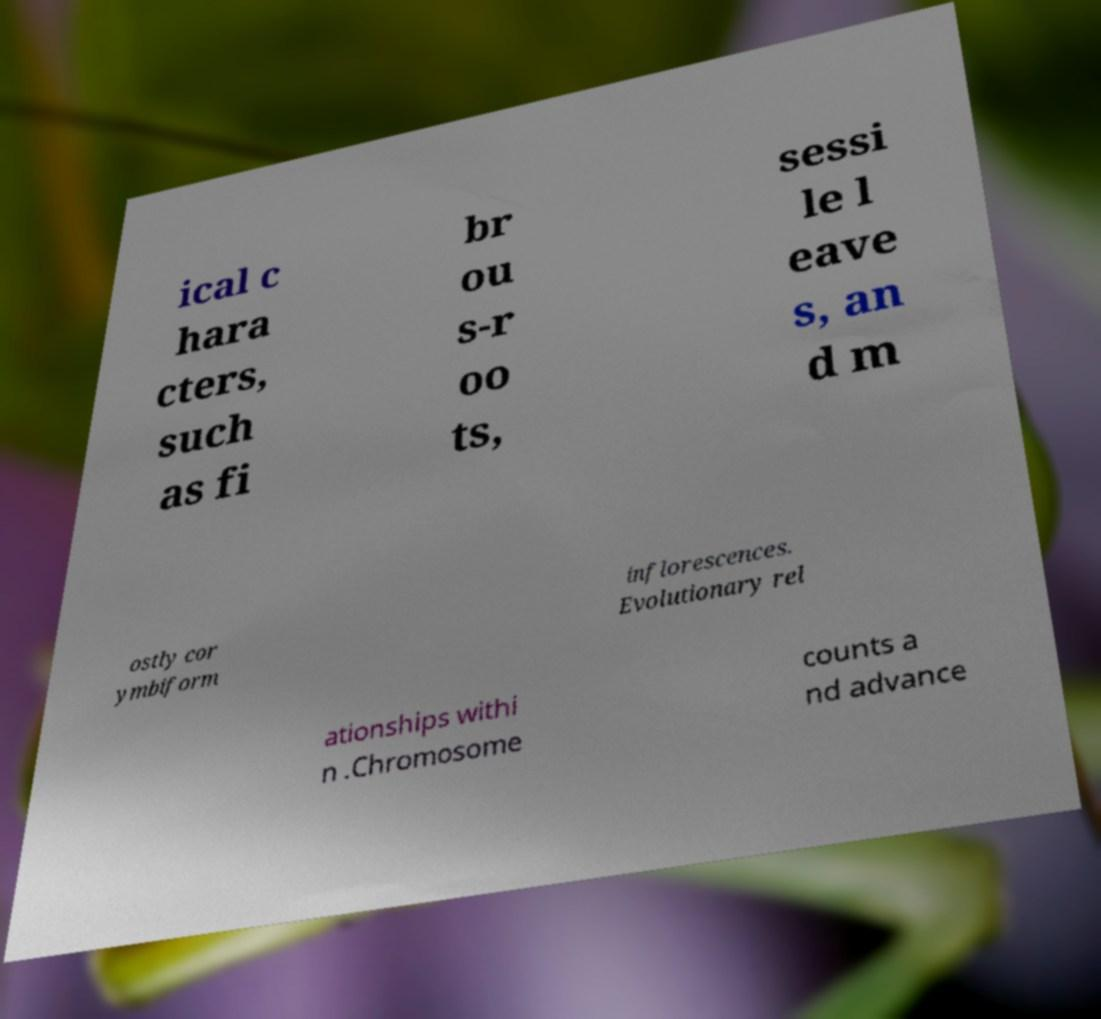Could you extract and type out the text from this image? ical c hara cters, such as fi br ou s-r oo ts, sessi le l eave s, an d m ostly cor ymbiform inflorescences. Evolutionary rel ationships withi n .Chromosome counts a nd advance 